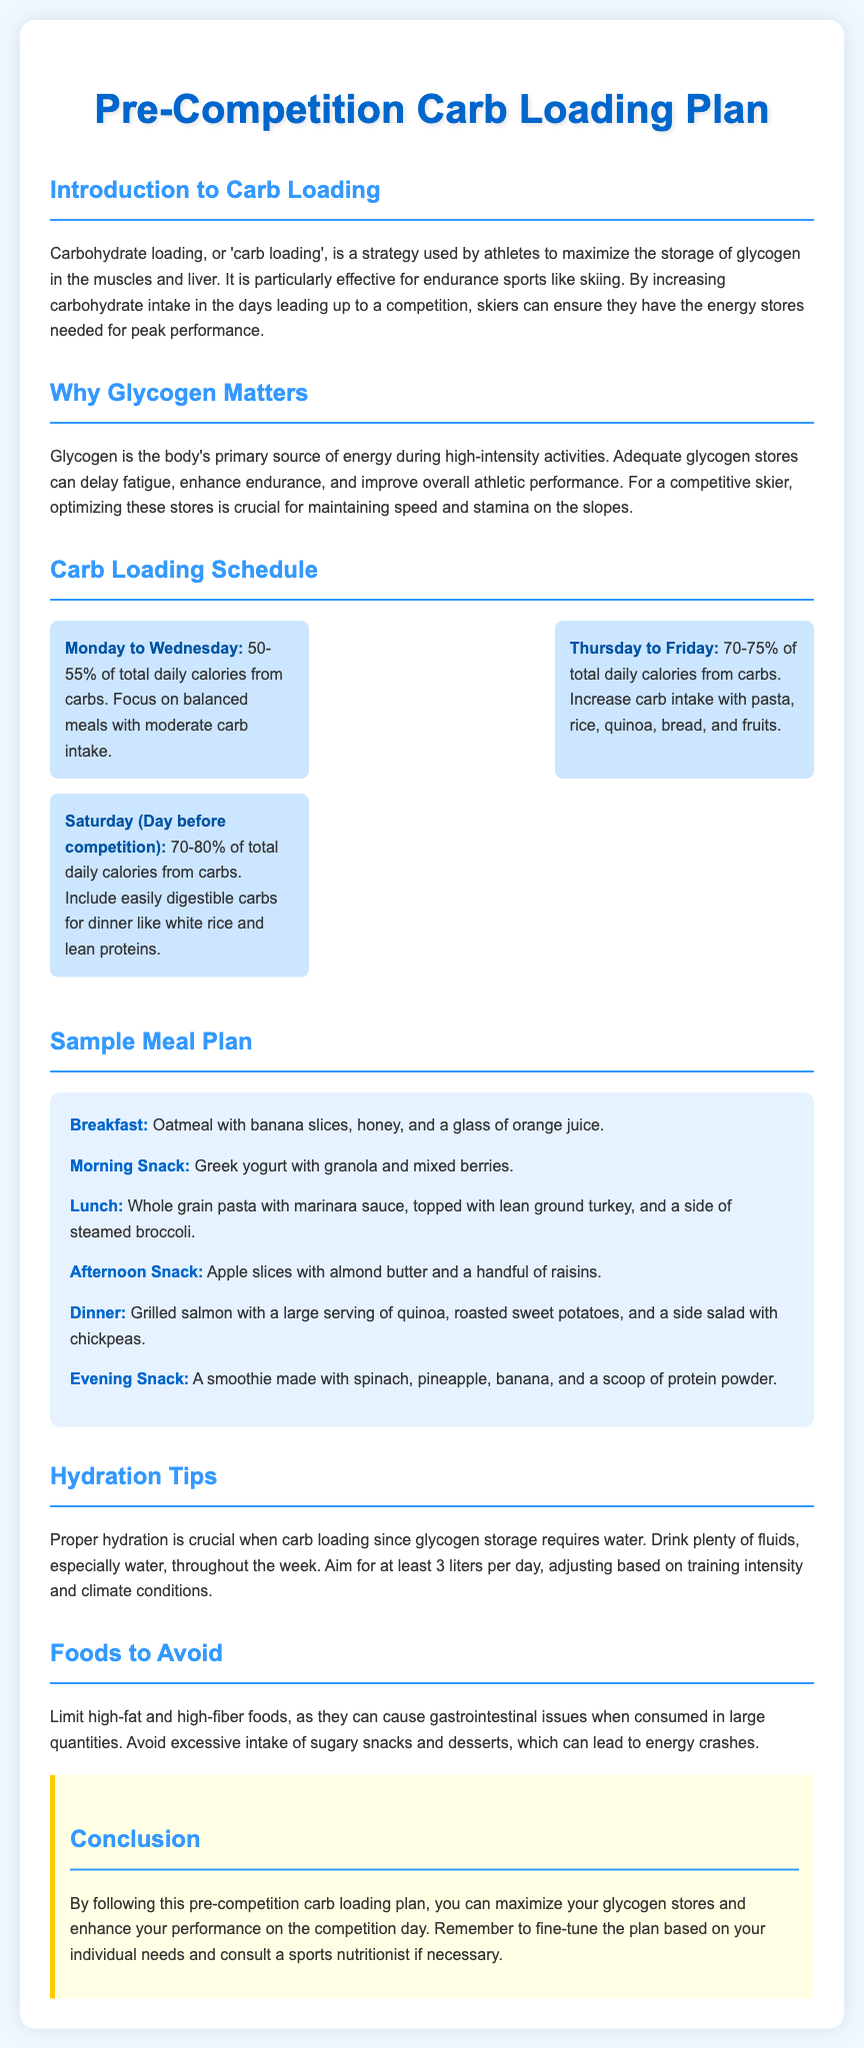What is the primary purpose of carb loading? The primary purpose of carb loading is to maximize the storage of glycogen in the muscles and liver, ensuring energy stores for peak performance.
Answer: To maximize glycogen storage How much of total daily calories should come from carbs on Saturday? On Saturday (the day before competition), 70-80% of total daily calories should come from carbs.
Answer: 70-80% What type of meal is suggested for breakfast? The suggested breakfast is oatmeal with banana slices, honey, and a glass of orange juice.
Answer: Oatmeal with banana slices What should be limited in the diet during carb loading? High-fat and high-fiber foods should be limited in the diet during carb loading.
Answer: High-fat and high-fiber foods How many liters of water should be aimed for daily? The plan suggests aiming for at least 3 liters of water daily.
Answer: 3 liters What is recommended for the evening snack? A smoothie made with spinach, pineapple, banana, and a scoop of protein powder is recommended for the evening snack.
Answer: A smoothie What type of foods are to be avoided to prevent energy crashes? Excessive intake of sugary snacks and desserts should be avoided to prevent energy crashes.
Answer: Sugary snacks and desserts What is the main source of energy during high-intensity activities? Glycogen is the body's primary source of energy during high-intensity activities.
Answer: Glycogen 